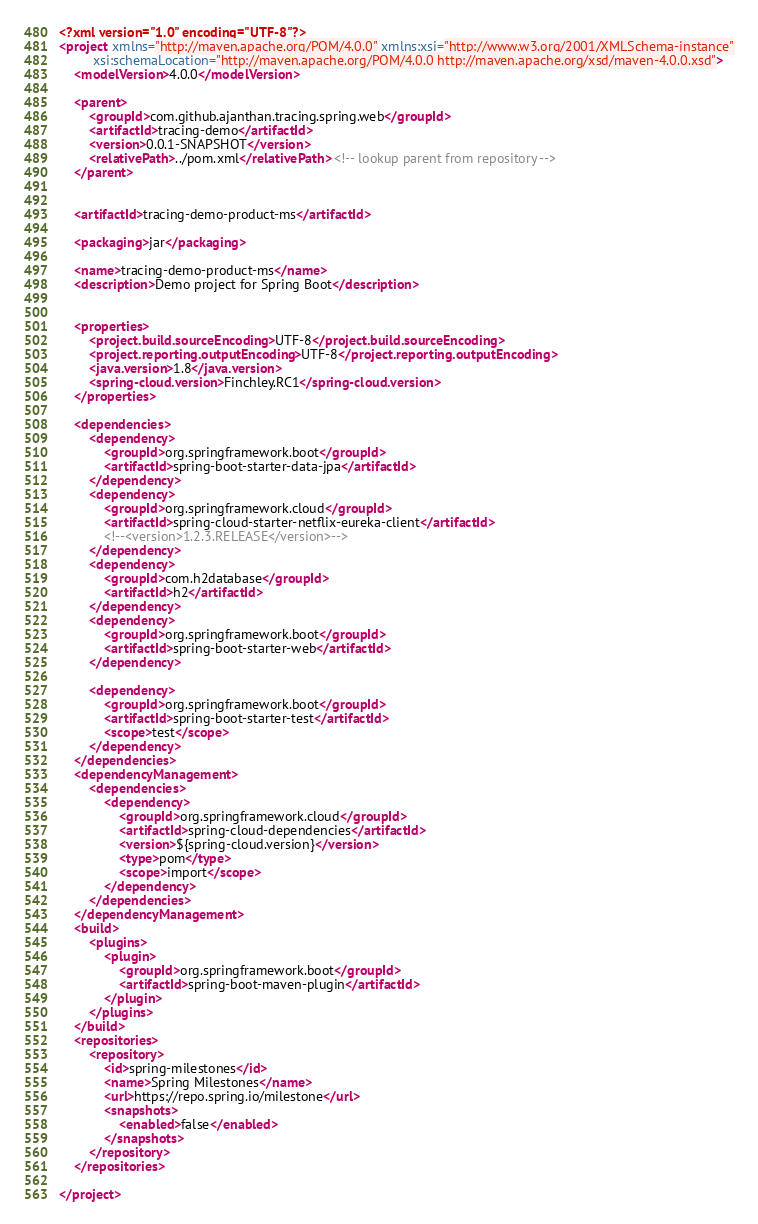Convert code to text. <code><loc_0><loc_0><loc_500><loc_500><_XML_><?xml version="1.0" encoding="UTF-8"?>
<project xmlns="http://maven.apache.org/POM/4.0.0" xmlns:xsi="http://www.w3.org/2001/XMLSchema-instance"
         xsi:schemaLocation="http://maven.apache.org/POM/4.0.0 http://maven.apache.org/xsd/maven-4.0.0.xsd">
    <modelVersion>4.0.0</modelVersion>

    <parent>
        <groupId>com.github.ajanthan.tracing.spring.web</groupId>
        <artifactId>tracing-demo</artifactId>
        <version>0.0.1-SNAPSHOT</version>
        <relativePath>../pom.xml</relativePath> <!-- lookup parent from repository -->
    </parent>


    <artifactId>tracing-demo-product-ms</artifactId>

    <packaging>jar</packaging>

    <name>tracing-demo-product-ms</name>
    <description>Demo project for Spring Boot</description>


    <properties>
        <project.build.sourceEncoding>UTF-8</project.build.sourceEncoding>
        <project.reporting.outputEncoding>UTF-8</project.reporting.outputEncoding>
        <java.version>1.8</java.version>
        <spring-cloud.version>Finchley.RC1</spring-cloud.version>
    </properties>

    <dependencies>
        <dependency>
            <groupId>org.springframework.boot</groupId>
            <artifactId>spring-boot-starter-data-jpa</artifactId>
        </dependency>
        <dependency>
            <groupId>org.springframework.cloud</groupId>
            <artifactId>spring-cloud-starter-netflix-eureka-client</artifactId>
            <!--<version>1.2.3.RELEASE</version>-->
        </dependency>
        <dependency>
            <groupId>com.h2database</groupId>
            <artifactId>h2</artifactId>
        </dependency>
        <dependency>
            <groupId>org.springframework.boot</groupId>
            <artifactId>spring-boot-starter-web</artifactId>
        </dependency>

        <dependency>
            <groupId>org.springframework.boot</groupId>
            <artifactId>spring-boot-starter-test</artifactId>
            <scope>test</scope>
        </dependency>
    </dependencies>
    <dependencyManagement>
        <dependencies>
            <dependency>
                <groupId>org.springframework.cloud</groupId>
                <artifactId>spring-cloud-dependencies</artifactId>
                <version>${spring-cloud.version}</version>
                <type>pom</type>
                <scope>import</scope>
            </dependency>
        </dependencies>
    </dependencyManagement>
    <build>
        <plugins>
            <plugin>
                <groupId>org.springframework.boot</groupId>
                <artifactId>spring-boot-maven-plugin</artifactId>
            </plugin>
        </plugins>
    </build>
    <repositories>
        <repository>
            <id>spring-milestones</id>
            <name>Spring Milestones</name>
            <url>https://repo.spring.io/milestone</url>
            <snapshots>
                <enabled>false</enabled>
            </snapshots>
        </repository>
    </repositories>

</project>
</code> 